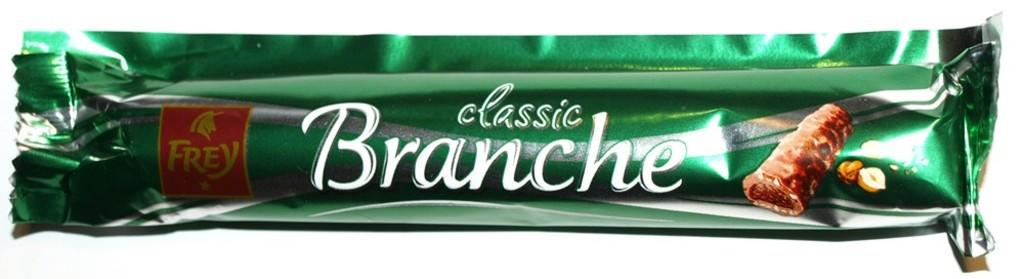What is the main object in the image? There is a food packet in the image. What can be found on the wrapper of the food packet? There is text and a picture of a chocolate on the wrapper. What type of badge is attached to the chocolate in the image? There is no badge attached to the chocolate in the image; it is a picture of a chocolate on the wrapper of the food packet. How many bears are visible in the image? There are no bears present in the image. 